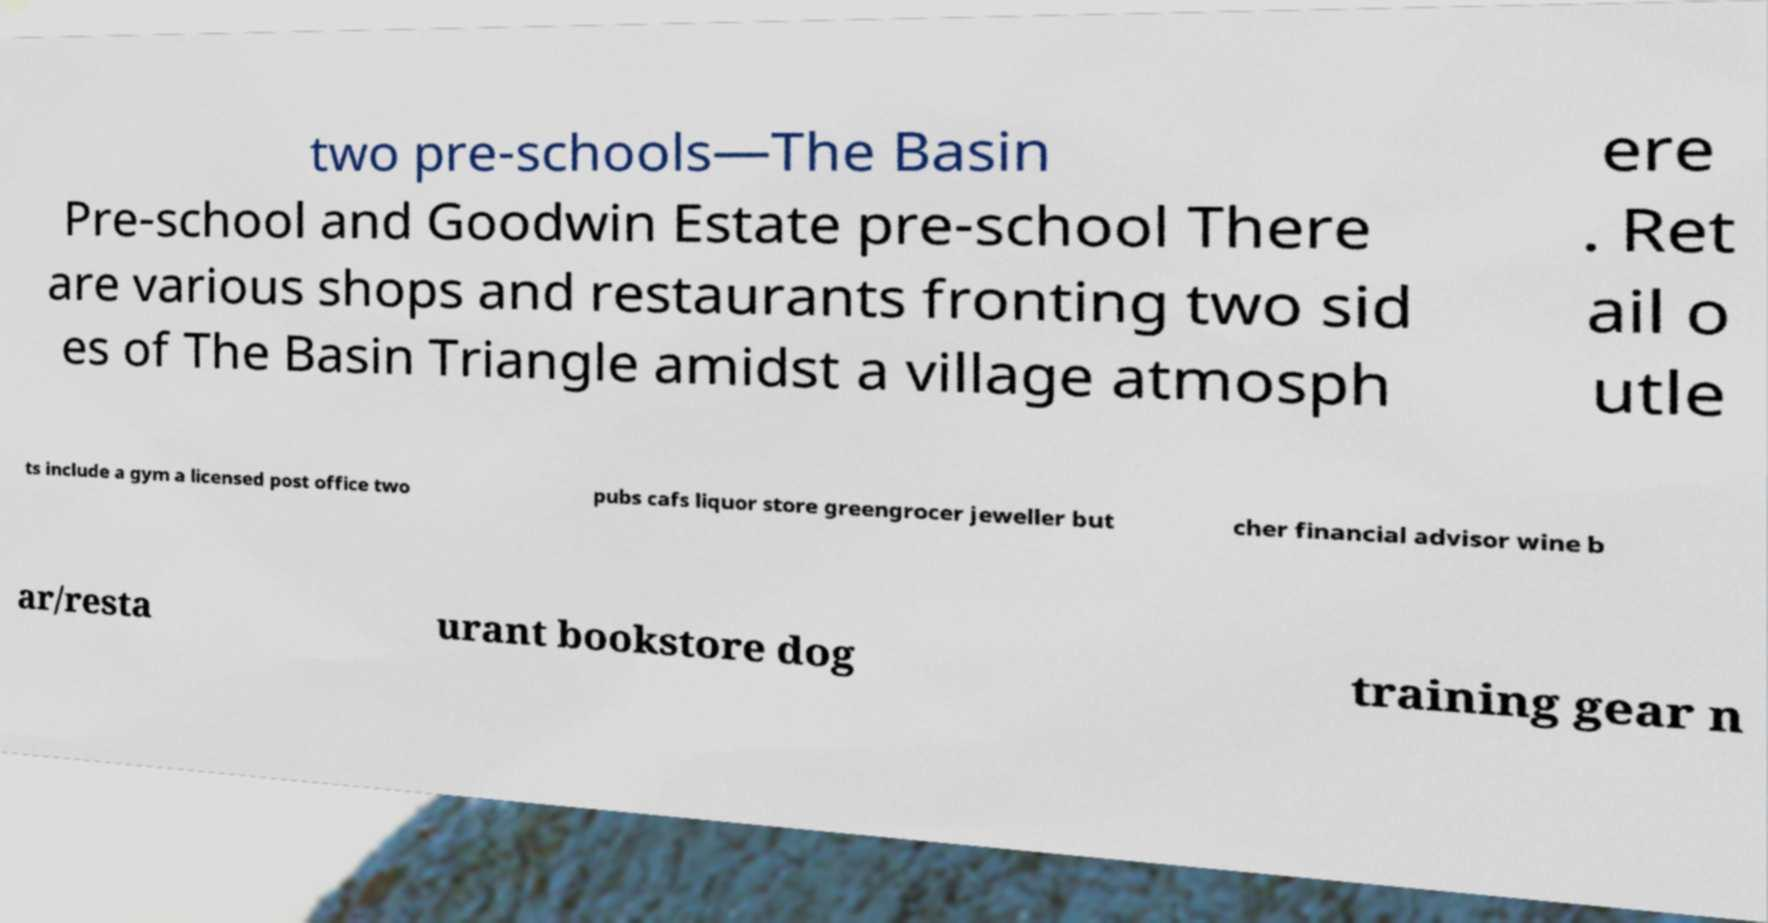For documentation purposes, I need the text within this image transcribed. Could you provide that? two pre-schools—The Basin Pre-school and Goodwin Estate pre-school There are various shops and restaurants fronting two sid es of The Basin Triangle amidst a village atmosph ere . Ret ail o utle ts include a gym a licensed post office two pubs cafs liquor store greengrocer jeweller but cher financial advisor wine b ar/resta urant bookstore dog training gear n 